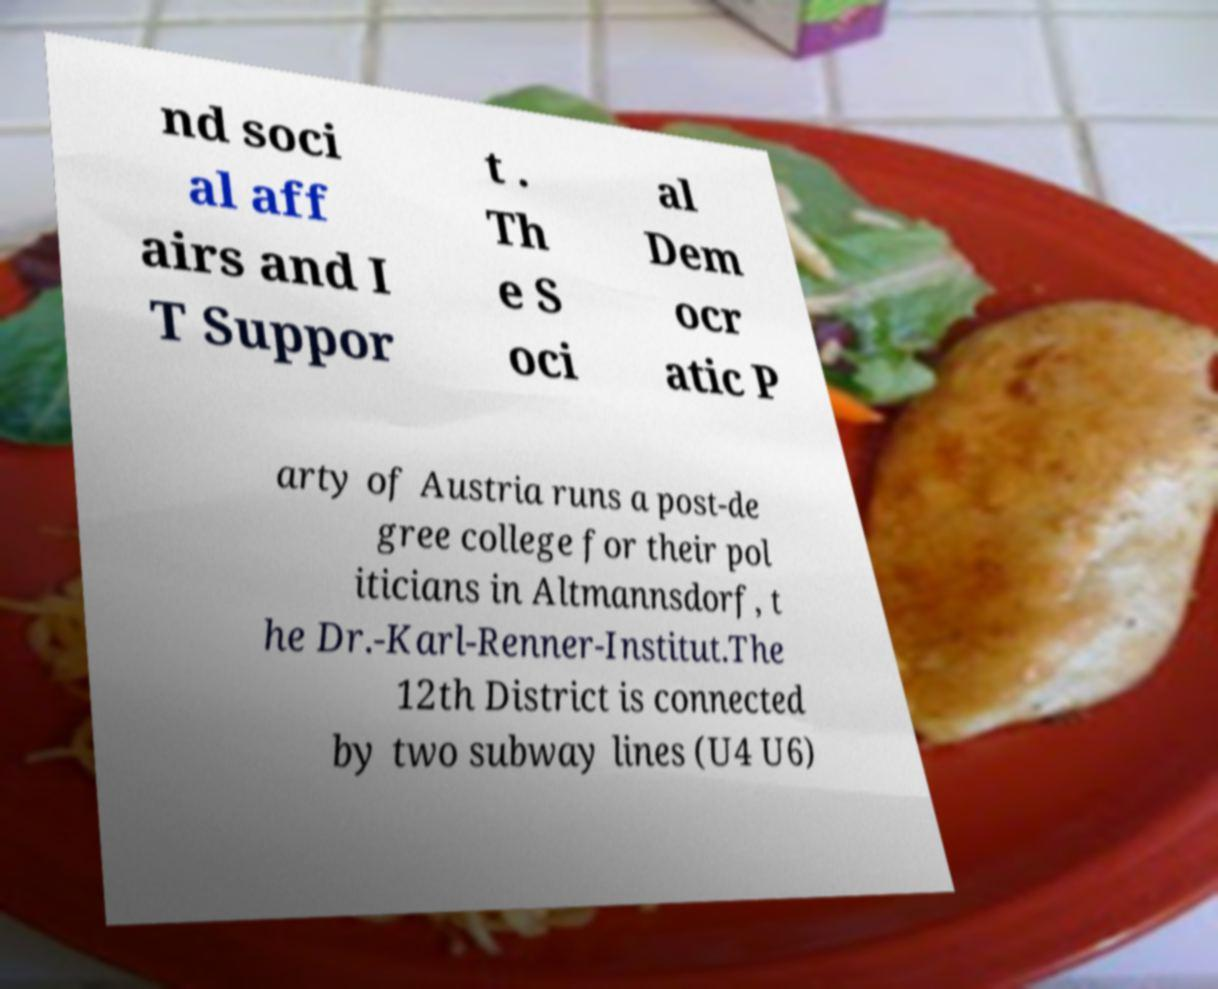Can you accurately transcribe the text from the provided image for me? nd soci al aff airs and I T Suppor t . Th e S oci al Dem ocr atic P arty of Austria runs a post-de gree college for their pol iticians in Altmannsdorf, t he Dr.-Karl-Renner-Institut.The 12th District is connected by two subway lines (U4 U6) 